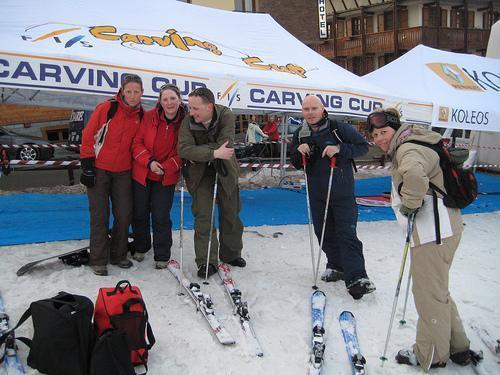How many people are looking at the camera?
Give a very brief answer. 4. How many people are there?
Give a very brief answer. 5. How many backpacks are in the picture?
Give a very brief answer. 3. 